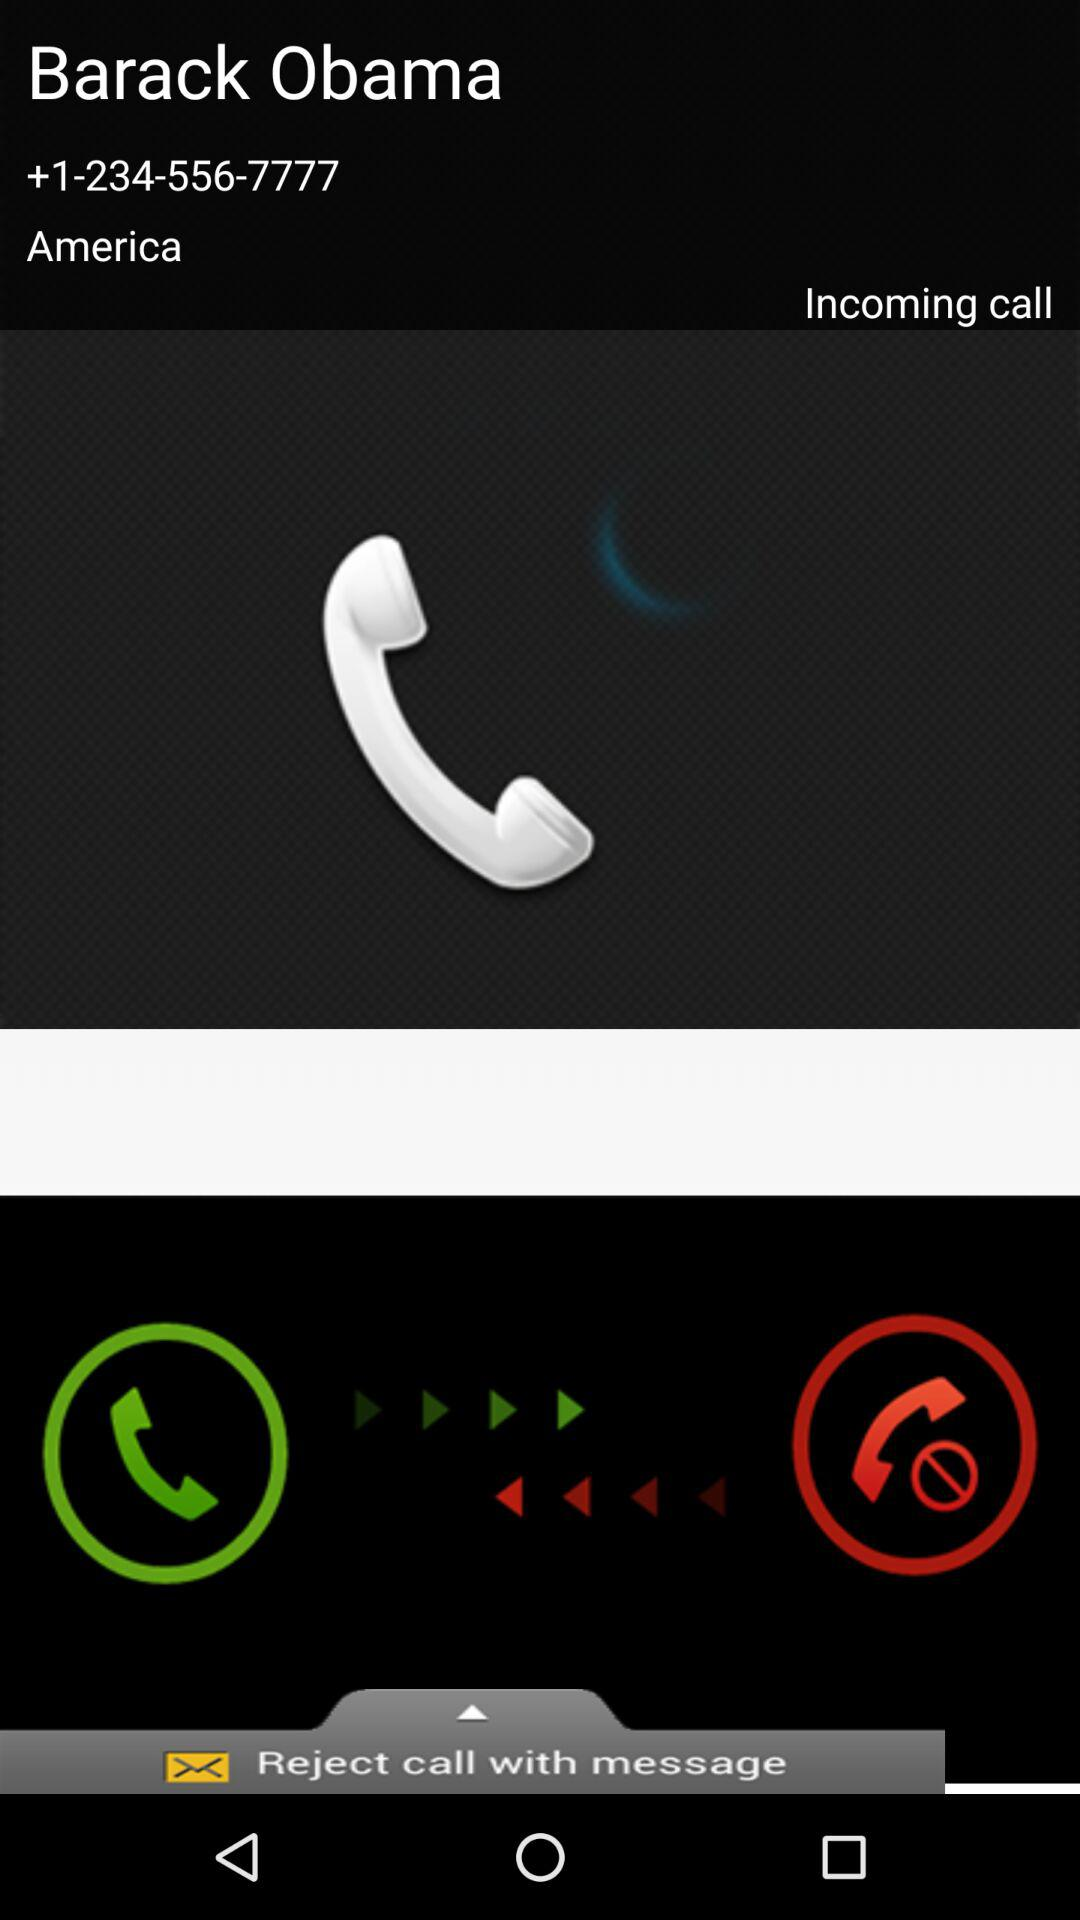What is the contact number? The contact number is +1-234-556-7777. 